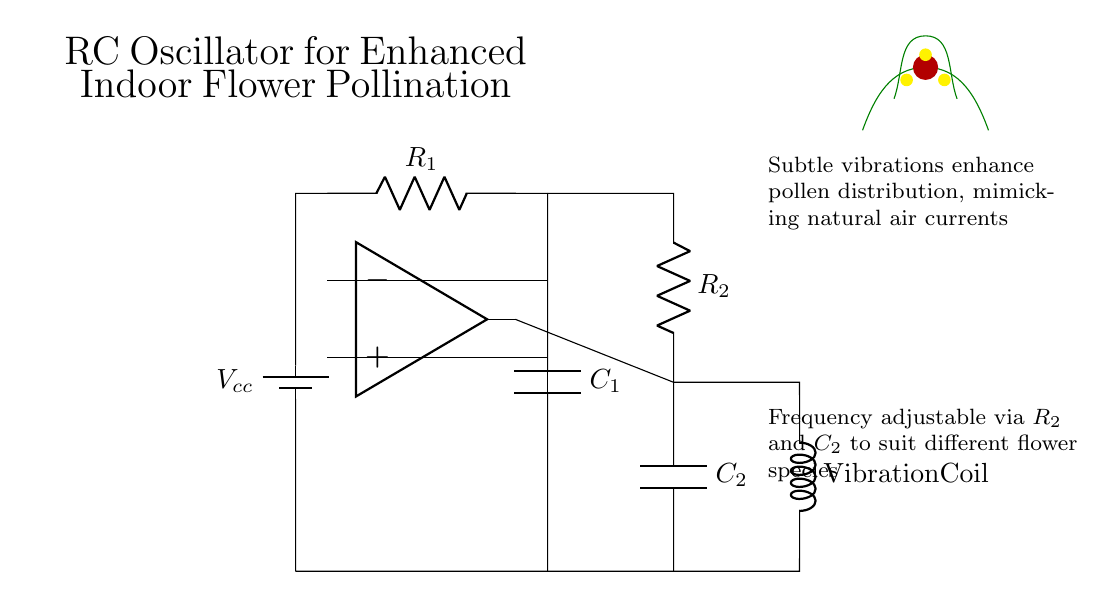What is the value of the first resistor? The first resistor, labeled as R1 in the circuit diagram, does not have a specific value indicated. Typically, it is determined based on the desired frequency of oscillation.
Answer: Not specified What type of circuit is shown in the diagram? The circuit diagram depicts an RC oscillator circuit, characterized by the use of resistors and capacitors to generate oscillations. This type of circuit is commonly used for signal generation and timing applications.
Answer: RC oscillator What is the function of the vibration coil in this circuit? The vibration coil serves as an actuator that produces subtle vibrations to enhance pollination, mimicking the natural vibrations caused by air currents or buzzing insects around flowers.
Answer: Enhance pollination How can the frequency of the oscillator be adjusted? The frequency of the oscillator can be adjusted by modifying the values of R2 and C2, which affects the charge and discharge time, thereby influencing the oscillation frequency.
Answer: Adjust R2 and C2 What is the purpose of the op-amp in this circuit? The op-amp amplifies the voltage difference between its input terminals, providing the necessary feedback to sustain oscillations in the RC oscillator. This feedback creates a stable and consistent oscillation output.
Answer: Amplify voltage difference What role do C1 and C2 play in the circuit? Both C1 and C2 are capacitors that store and release energy, influencing the timing characteristics of the oscillator. Their charge and discharge rates, determined by the resistor values, dictate the oscillation frequency of the circuit.
Answer: Timing characteristics What component is used to indicate the DC power supply? A battery is used to indicate the DC power supply in the circuit diagram, providing the necessary voltage (not specified) to power the oscillating circuit components.
Answer: Battery 